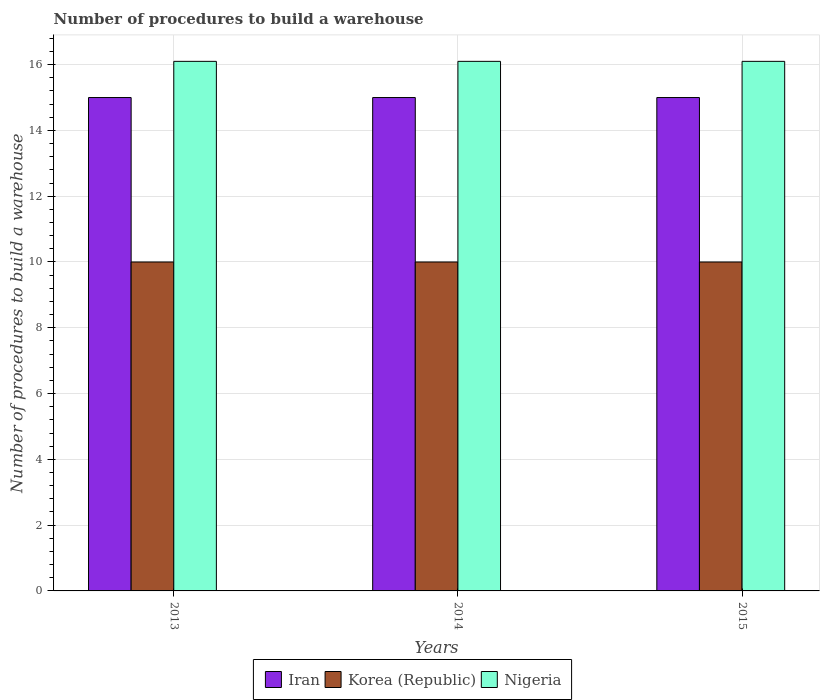How many groups of bars are there?
Give a very brief answer. 3. Are the number of bars per tick equal to the number of legend labels?
Offer a terse response. Yes. Are the number of bars on each tick of the X-axis equal?
Offer a very short reply. Yes. How many bars are there on the 2nd tick from the right?
Your answer should be compact. 3. In how many cases, is the number of bars for a given year not equal to the number of legend labels?
Provide a short and direct response. 0. What is the number of procedures to build a warehouse in in Iran in 2013?
Give a very brief answer. 15. Across all years, what is the maximum number of procedures to build a warehouse in in Korea (Republic)?
Offer a terse response. 10. Across all years, what is the minimum number of procedures to build a warehouse in in Iran?
Offer a very short reply. 15. What is the total number of procedures to build a warehouse in in Korea (Republic) in the graph?
Make the answer very short. 30. What is the difference between the number of procedures to build a warehouse in in Nigeria in 2014 and the number of procedures to build a warehouse in in Korea (Republic) in 2013?
Keep it short and to the point. 6.1. In the year 2014, what is the difference between the number of procedures to build a warehouse in in Korea (Republic) and number of procedures to build a warehouse in in Iran?
Offer a very short reply. -5. In how many years, is the number of procedures to build a warehouse in in Nigeria greater than 16.4?
Make the answer very short. 0. Is the number of procedures to build a warehouse in in Iran in 2013 less than that in 2015?
Provide a succinct answer. No. What is the difference between the highest and the second highest number of procedures to build a warehouse in in Nigeria?
Give a very brief answer. 0. What does the 2nd bar from the left in 2013 represents?
Provide a succinct answer. Korea (Republic). What does the 3rd bar from the right in 2014 represents?
Your answer should be very brief. Iran. Are the values on the major ticks of Y-axis written in scientific E-notation?
Offer a terse response. No. Where does the legend appear in the graph?
Keep it short and to the point. Bottom center. What is the title of the graph?
Provide a succinct answer. Number of procedures to build a warehouse. What is the label or title of the Y-axis?
Make the answer very short. Number of procedures to build a warehouse. What is the Number of procedures to build a warehouse of Iran in 2014?
Your answer should be very brief. 15. What is the Number of procedures to build a warehouse of Korea (Republic) in 2014?
Offer a very short reply. 10. What is the Number of procedures to build a warehouse in Korea (Republic) in 2015?
Give a very brief answer. 10. What is the Number of procedures to build a warehouse of Nigeria in 2015?
Your response must be concise. 16.1. Across all years, what is the minimum Number of procedures to build a warehouse of Iran?
Your answer should be very brief. 15. Across all years, what is the minimum Number of procedures to build a warehouse in Nigeria?
Give a very brief answer. 16.1. What is the total Number of procedures to build a warehouse in Iran in the graph?
Ensure brevity in your answer.  45. What is the total Number of procedures to build a warehouse in Korea (Republic) in the graph?
Offer a very short reply. 30. What is the total Number of procedures to build a warehouse in Nigeria in the graph?
Your response must be concise. 48.3. What is the difference between the Number of procedures to build a warehouse of Korea (Republic) in 2013 and that in 2014?
Keep it short and to the point. 0. What is the difference between the Number of procedures to build a warehouse of Iran in 2013 and that in 2015?
Provide a short and direct response. 0. What is the difference between the Number of procedures to build a warehouse of Korea (Republic) in 2013 and that in 2015?
Give a very brief answer. 0. What is the difference between the Number of procedures to build a warehouse of Nigeria in 2013 and that in 2015?
Your response must be concise. 0. What is the difference between the Number of procedures to build a warehouse in Korea (Republic) in 2014 and that in 2015?
Give a very brief answer. 0. What is the difference between the Number of procedures to build a warehouse of Iran in 2013 and the Number of procedures to build a warehouse of Korea (Republic) in 2014?
Ensure brevity in your answer.  5. What is the difference between the Number of procedures to build a warehouse of Korea (Republic) in 2013 and the Number of procedures to build a warehouse of Nigeria in 2014?
Offer a very short reply. -6.1. What is the difference between the Number of procedures to build a warehouse in Iran in 2013 and the Number of procedures to build a warehouse in Korea (Republic) in 2015?
Ensure brevity in your answer.  5. What is the difference between the Number of procedures to build a warehouse of Iran in 2013 and the Number of procedures to build a warehouse of Nigeria in 2015?
Make the answer very short. -1.1. What is the difference between the Number of procedures to build a warehouse of Iran in 2014 and the Number of procedures to build a warehouse of Korea (Republic) in 2015?
Provide a succinct answer. 5. What is the average Number of procedures to build a warehouse of Iran per year?
Your response must be concise. 15. In the year 2013, what is the difference between the Number of procedures to build a warehouse in Iran and Number of procedures to build a warehouse in Nigeria?
Your response must be concise. -1.1. In the year 2014, what is the difference between the Number of procedures to build a warehouse of Iran and Number of procedures to build a warehouse of Nigeria?
Make the answer very short. -1.1. In the year 2014, what is the difference between the Number of procedures to build a warehouse of Korea (Republic) and Number of procedures to build a warehouse of Nigeria?
Your answer should be compact. -6.1. In the year 2015, what is the difference between the Number of procedures to build a warehouse in Iran and Number of procedures to build a warehouse in Korea (Republic)?
Ensure brevity in your answer.  5. In the year 2015, what is the difference between the Number of procedures to build a warehouse of Iran and Number of procedures to build a warehouse of Nigeria?
Ensure brevity in your answer.  -1.1. What is the ratio of the Number of procedures to build a warehouse in Nigeria in 2013 to that in 2014?
Your answer should be very brief. 1. What is the ratio of the Number of procedures to build a warehouse of Iran in 2013 to that in 2015?
Ensure brevity in your answer.  1. What is the ratio of the Number of procedures to build a warehouse in Nigeria in 2013 to that in 2015?
Give a very brief answer. 1. What is the ratio of the Number of procedures to build a warehouse of Korea (Republic) in 2014 to that in 2015?
Offer a terse response. 1. What is the ratio of the Number of procedures to build a warehouse of Nigeria in 2014 to that in 2015?
Give a very brief answer. 1. What is the difference between the highest and the lowest Number of procedures to build a warehouse of Nigeria?
Your answer should be very brief. 0. 